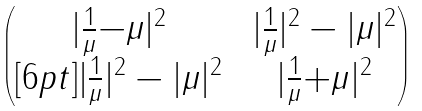<formula> <loc_0><loc_0><loc_500><loc_500>\begin{pmatrix} | \frac { 1 } { \mu } { - } \mu | ^ { 2 } & \ | \frac { 1 } { \mu } | ^ { 2 } - | \mu | ^ { 2 } \\ [ 6 p t ] | \frac { 1 } { \mu } | ^ { 2 } - | \mu | ^ { 2 } & \ | \frac { 1 } { \mu } { + } \mu | ^ { 2 } \end{pmatrix}</formula> 